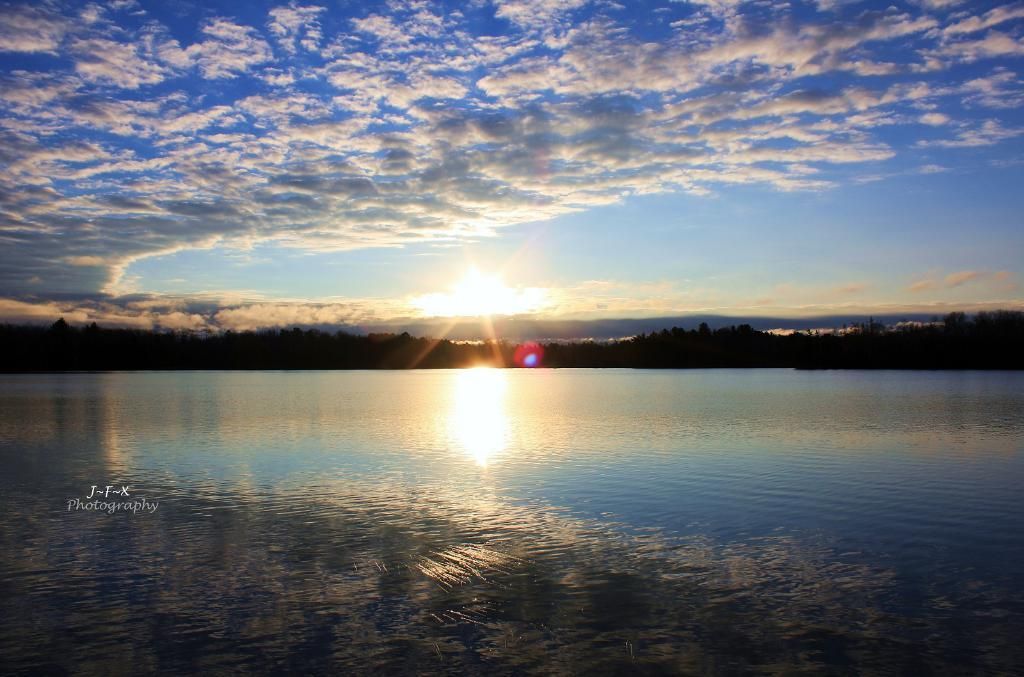What is the primary element visible in the image? There is water in the image. What other natural elements can be seen in the image? There are trees in the image. How would you describe the sky in the image? The sky is blue and cloudy in the image. Can you see any sunlight in the image? Yes, sunlight is visible in the image. Where is the text located in the image? The text is at the bottom left corner of the image. What is the name of the baby born in the image? There is no baby or birth depicted in the image; it features water, trees, a blue and cloudy sky, sunlight, and text at the bottom left corner. 